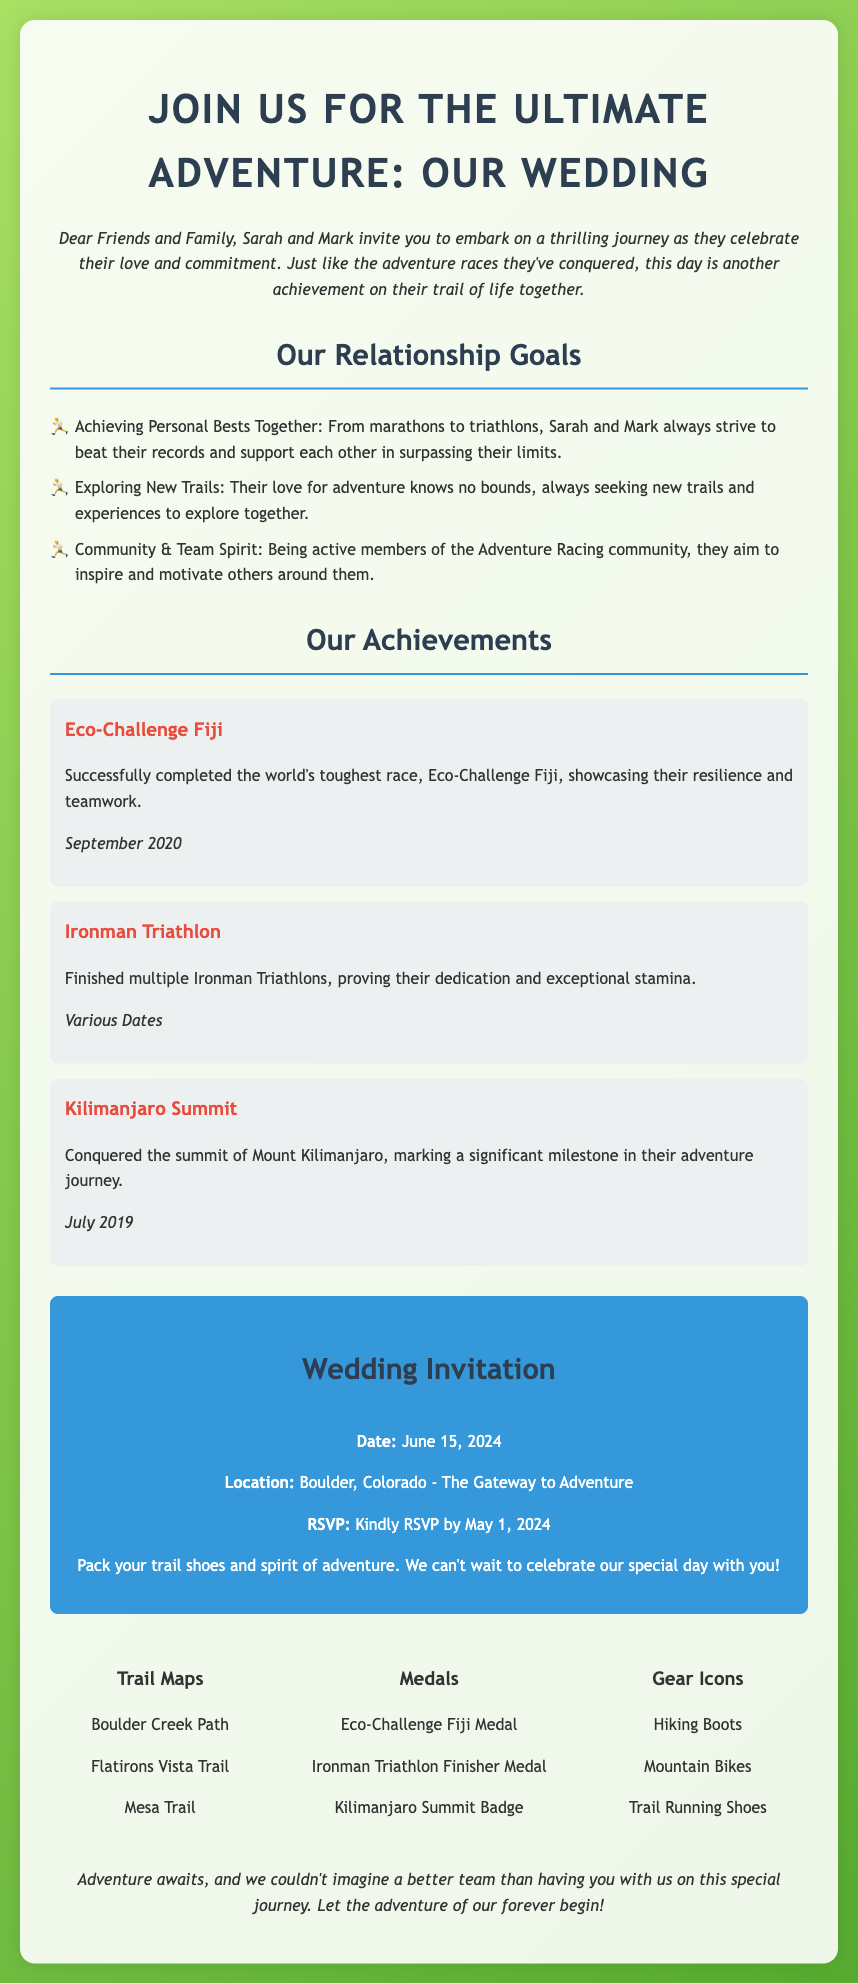What is the date of the wedding? The document specifies the wedding date as June 15, 2024.
Answer: June 15, 2024 Where is the wedding location? The invitation mentions Boulder, Colorado as the location for the wedding.
Answer: Boulder, Colorado What is one of the achievements listed? The achievements section includes the Eco-Challenge Fiji, Ironman Triathlon, and Kilimanjaro Summit.
Answer: Eco-Challenge Fiji What should guests pack for the wedding? The invitation suggests packing trail shoes and a spirit of adventure.
Answer: Trail shoes What is the RSVP deadline? The document indicates that guests should kindly RSVP by May 1, 2024.
Answer: May 1, 2024 How many relationship goals are mentioned? There are three relationship goals listed in the invitation.
Answer: Three What type of theme does the invitation have? The overall theme of the invitation revolves around adventure racing and outdoor activities.
Answer: Adventure Racing What is one of the design elements included? The document lists trail maps, medals, and gear icons as part of the design elements.
Answer: Trail maps What is the primary color of the invitation background? The background of the invitation has a linear gradient with green hues.
Answer: Green 